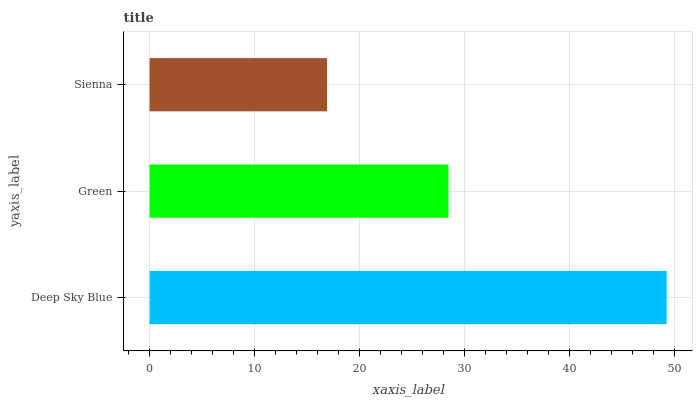Is Sienna the minimum?
Answer yes or no. Yes. Is Deep Sky Blue the maximum?
Answer yes or no. Yes. Is Green the minimum?
Answer yes or no. No. Is Green the maximum?
Answer yes or no. No. Is Deep Sky Blue greater than Green?
Answer yes or no. Yes. Is Green less than Deep Sky Blue?
Answer yes or no. Yes. Is Green greater than Deep Sky Blue?
Answer yes or no. No. Is Deep Sky Blue less than Green?
Answer yes or no. No. Is Green the high median?
Answer yes or no. Yes. Is Green the low median?
Answer yes or no. Yes. Is Deep Sky Blue the high median?
Answer yes or no. No. Is Sienna the low median?
Answer yes or no. No. 